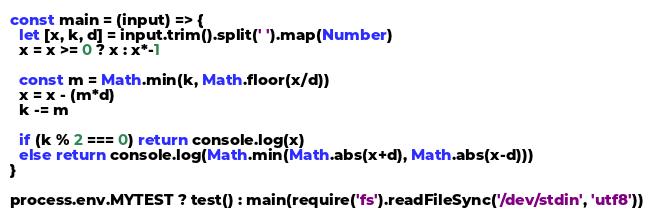Convert code to text. <code><loc_0><loc_0><loc_500><loc_500><_JavaScript_>const main = (input) => {
  let [x, k, d] = input.trim().split(' ').map(Number)
  x = x >= 0 ? x : x*-1

  const m = Math.min(k, Math.floor(x/d))
  x = x - (m*d)
  k -= m

  if (k % 2 === 0) return console.log(x)
  else return console.log(Math.min(Math.abs(x+d), Math.abs(x-d)))
}

process.env.MYTEST ? test() : main(require('fs').readFileSync('/dev/stdin', 'utf8'))</code> 